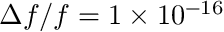<formula> <loc_0><loc_0><loc_500><loc_500>\Delta f / f = 1 \times 1 0 ^ { - 1 6 }</formula> 